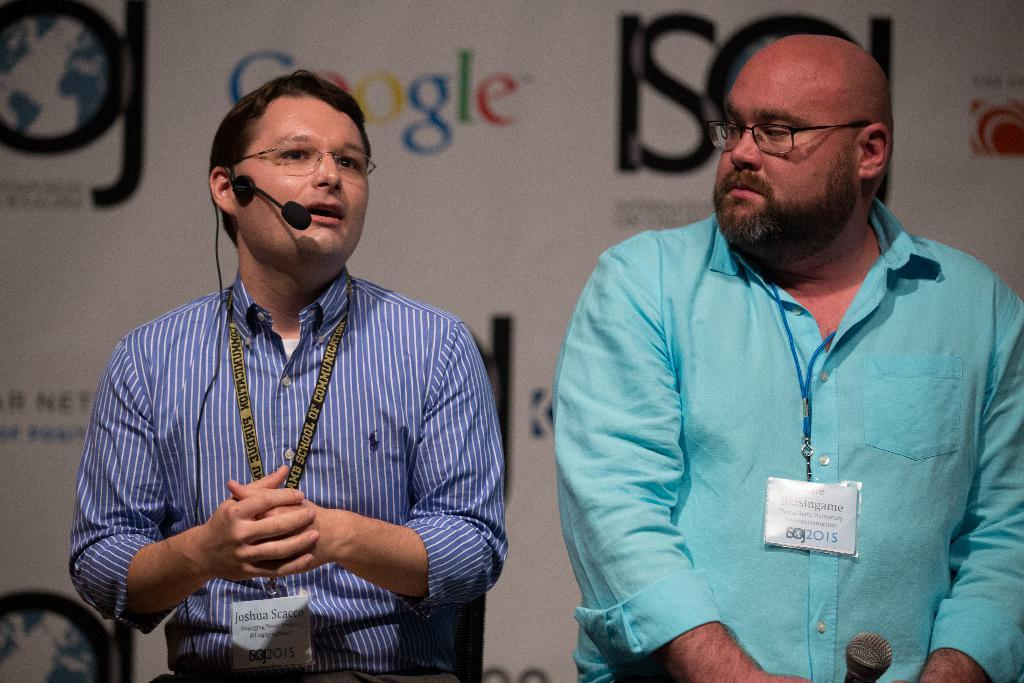How many people are in the image? There are two men in the center of the image. What can be seen in the background of the image? There is a poster in the background of the image. What type of skirt is the man on the left wearing in the image? There is no skirt present in the image, as both men are wearing pants. 